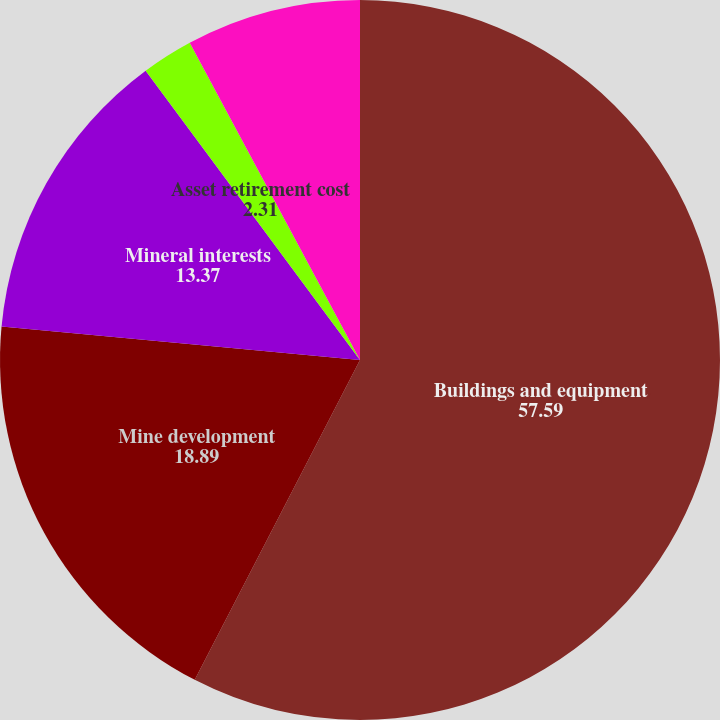<chart> <loc_0><loc_0><loc_500><loc_500><pie_chart><fcel>Buildings and equipment<fcel>Mine development<fcel>Mineral interests<fcel>Asset retirement cost<fcel>Leased assets included above<nl><fcel>57.59%<fcel>18.89%<fcel>13.37%<fcel>2.31%<fcel>7.84%<nl></chart> 